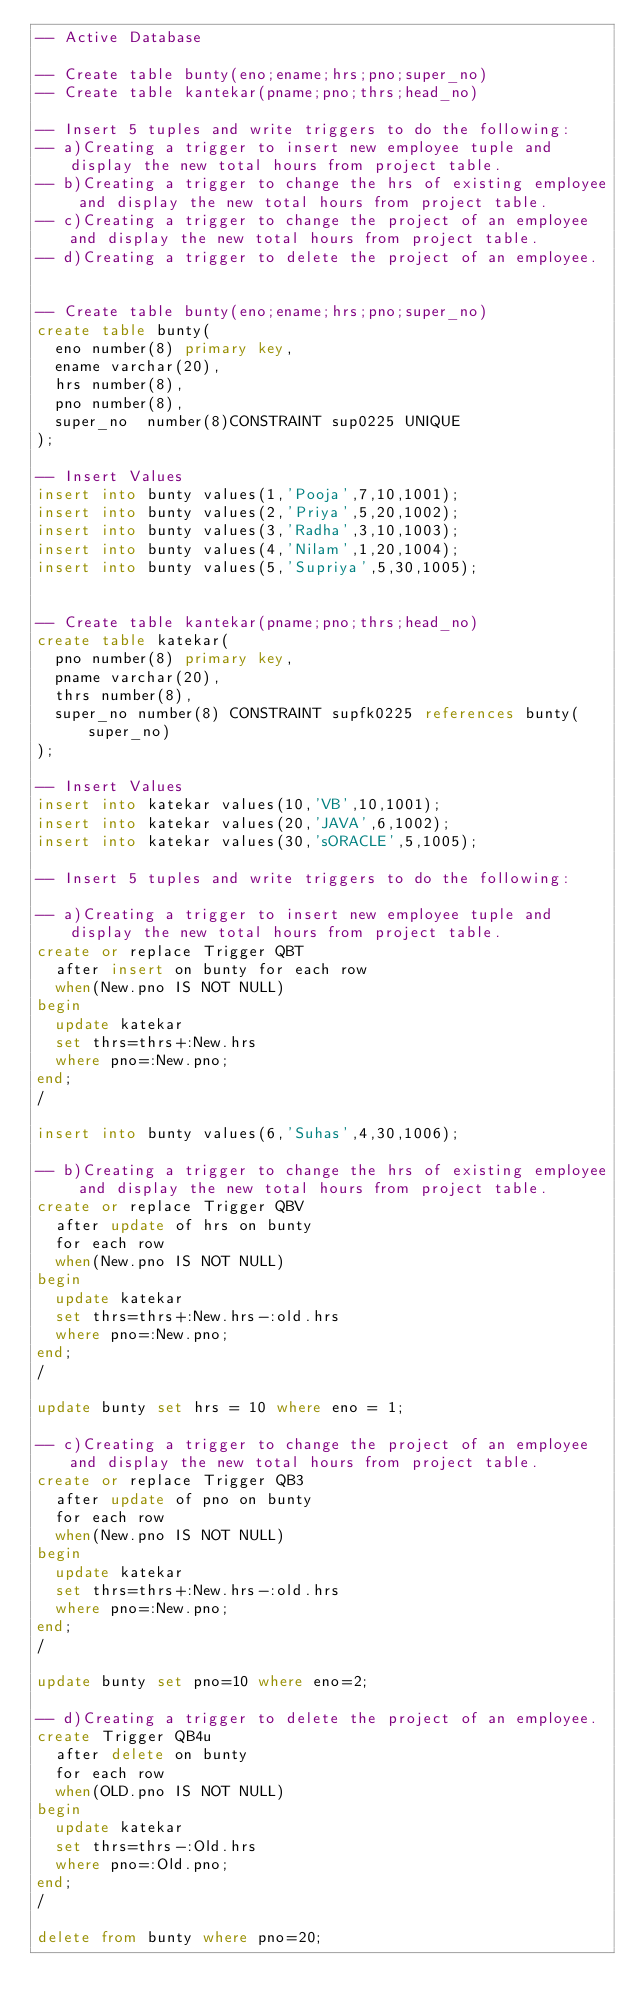<code> <loc_0><loc_0><loc_500><loc_500><_SQL_>-- Active Database

-- Create table bunty(eno;ename;hrs;pno;super_no) 
-- Create table kantekar(pname;pno;thrs;head_no)

-- Insert 5 tuples and write triggers to do the following:
-- a)Creating a trigger to insert new employee tuple and display the new total hours from project table.
-- b)Creating a trigger to change the hrs of existing employee and display the new total hours from project table.
-- c)Creating a trigger to change the project of an employee and display the new total hours from project table.
-- d)Creating a trigger to delete the project of an employee.


-- Create table bunty(eno;ename;hrs;pno;super_no) 
create table bunty(
	eno number(8) primary key,
	ename varchar(20),
	hrs number(8),
	pno number(8),
	super_no  number(8)CONSTRAINT sup0225 UNIQUE
);

-- Insert Values
insert into bunty values(1,'Pooja',7,10,1001);
insert into bunty values(2,'Priya',5,20,1002);
insert into bunty values(3,'Radha',3,10,1003);
insert into bunty values(4,'Nilam',1,20,1004);
insert into bunty values(5,'Supriya',5,30,1005);


-- Create table kantekar(pname;pno;thrs;head_no)
create table katekar(	
	pno number(8) primary key,
	pname varchar(20),
	thrs number(8),
	super_no number(8) CONSTRAINT supfk0225 references bunty(super_no)
);

-- Insert Values
insert into katekar values(10,'VB',10,1001);
insert into katekar values(20,'JAVA',6,1002);
insert into katekar values(30,'sORACLE',5,1005);

-- Insert 5 tuples and write triggers to do the following:

-- a)Creating a trigger to insert new employee tuple and display the new total hours from project table.
create or replace Trigger QBT
 	after insert on bunty for each row
	when(New.pno IS NOT NULL)
begin
	update katekar
	set thrs=thrs+:New.hrs 
	where pno=:New.pno;	
end;
/

insert into bunty values(6,'Suhas',4,30,1006);

-- b)Creating a trigger to change the hrs of existing employee and display the new total hours from project table.
create or replace Trigger QBV
 	after update of hrs on bunty 
	for each row
	when(New.pno IS NOT NULL)
begin
	update katekar
	set thrs=thrs+:New.hrs-:old.hrs 
	where pno=:New.pno;	
end;
/

update bunty set hrs = 10 where eno = 1;

-- c)Creating a trigger to change the project of an employee and display the new total hours from project table.
create or replace Trigger QB3
 	after update of pno on bunty 
	for each row
	when(New.pno IS NOT NULL)
begin
	update katekar
	set thrs=thrs+:New.hrs-:old.hrs 
	where pno=:New.pno;	
end;
/

update bunty set pno=10 where eno=2;

-- d)Creating a trigger to delete the project of an employee.
create Trigger QB4u
	after delete on bunty
	for each row
	when(OLD.pno IS NOT NULL)
begin
	update katekar
	set thrs=thrs-:Old.hrs
	where pno=:Old.pno;
end;
/

delete from bunty where pno=20;</code> 